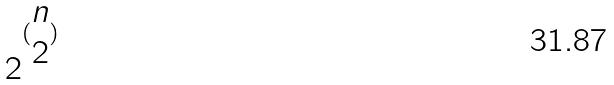<formula> <loc_0><loc_0><loc_500><loc_500>2 ^ { ( \begin{matrix} n \\ 2 \end{matrix} ) }</formula> 